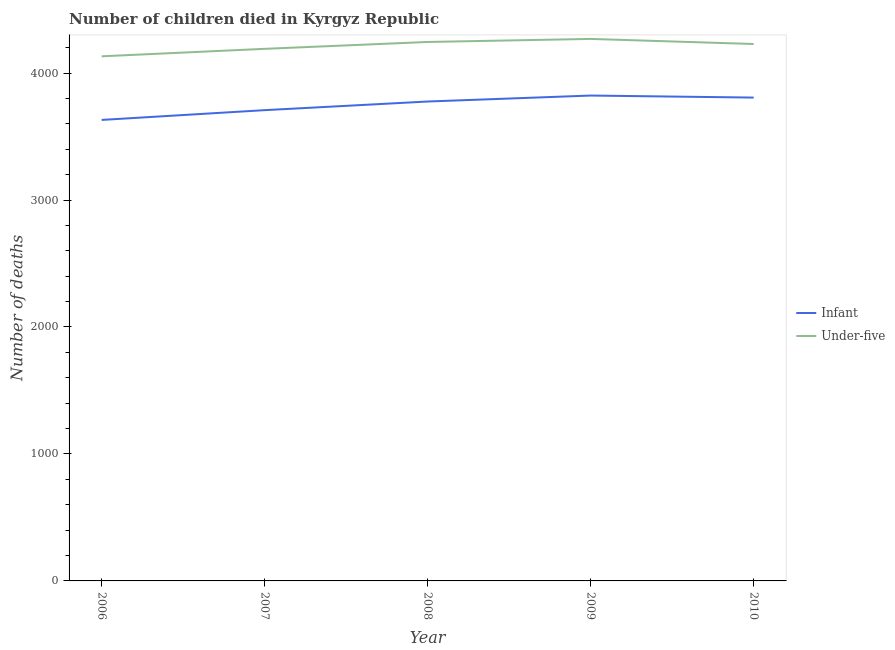How many different coloured lines are there?
Ensure brevity in your answer.  2. Does the line corresponding to number of under-five deaths intersect with the line corresponding to number of infant deaths?
Keep it short and to the point. No. What is the number of under-five deaths in 2009?
Your answer should be very brief. 4269. Across all years, what is the maximum number of infant deaths?
Your answer should be very brief. 3823. Across all years, what is the minimum number of under-five deaths?
Make the answer very short. 4132. In which year was the number of under-five deaths minimum?
Your answer should be very brief. 2006. What is the total number of infant deaths in the graph?
Provide a short and direct response. 1.87e+04. What is the difference between the number of infant deaths in 2007 and that in 2010?
Your answer should be very brief. -99. What is the difference between the number of under-five deaths in 2008 and the number of infant deaths in 2009?
Your response must be concise. 422. What is the average number of infant deaths per year?
Provide a succinct answer. 3749. In the year 2008, what is the difference between the number of infant deaths and number of under-five deaths?
Your response must be concise. -469. What is the ratio of the number of under-five deaths in 2006 to that in 2010?
Provide a short and direct response. 0.98. Is the number of infant deaths in 2007 less than that in 2008?
Give a very brief answer. Yes. What is the difference between the highest and the second highest number of infant deaths?
Make the answer very short. 16. What is the difference between the highest and the lowest number of infant deaths?
Your response must be concise. 192. Is the number of under-five deaths strictly greater than the number of infant deaths over the years?
Your answer should be compact. Yes. Is the number of infant deaths strictly less than the number of under-five deaths over the years?
Make the answer very short. Yes. How many lines are there?
Give a very brief answer. 2. How many years are there in the graph?
Offer a terse response. 5. What is the difference between two consecutive major ticks on the Y-axis?
Keep it short and to the point. 1000. Are the values on the major ticks of Y-axis written in scientific E-notation?
Provide a short and direct response. No. Does the graph contain grids?
Ensure brevity in your answer.  No. What is the title of the graph?
Offer a very short reply. Number of children died in Kyrgyz Republic. What is the label or title of the X-axis?
Your response must be concise. Year. What is the label or title of the Y-axis?
Offer a very short reply. Number of deaths. What is the Number of deaths in Infant in 2006?
Your answer should be very brief. 3631. What is the Number of deaths in Under-five in 2006?
Your answer should be very brief. 4132. What is the Number of deaths of Infant in 2007?
Offer a very short reply. 3708. What is the Number of deaths of Under-five in 2007?
Your answer should be very brief. 4191. What is the Number of deaths in Infant in 2008?
Your answer should be compact. 3776. What is the Number of deaths in Under-five in 2008?
Keep it short and to the point. 4245. What is the Number of deaths of Infant in 2009?
Ensure brevity in your answer.  3823. What is the Number of deaths of Under-five in 2009?
Offer a terse response. 4269. What is the Number of deaths in Infant in 2010?
Your answer should be compact. 3807. What is the Number of deaths in Under-five in 2010?
Offer a very short reply. 4229. Across all years, what is the maximum Number of deaths of Infant?
Your response must be concise. 3823. Across all years, what is the maximum Number of deaths in Under-five?
Keep it short and to the point. 4269. Across all years, what is the minimum Number of deaths in Infant?
Keep it short and to the point. 3631. Across all years, what is the minimum Number of deaths of Under-five?
Keep it short and to the point. 4132. What is the total Number of deaths in Infant in the graph?
Keep it short and to the point. 1.87e+04. What is the total Number of deaths of Under-five in the graph?
Offer a terse response. 2.11e+04. What is the difference between the Number of deaths in Infant in 2006 and that in 2007?
Make the answer very short. -77. What is the difference between the Number of deaths of Under-five in 2006 and that in 2007?
Make the answer very short. -59. What is the difference between the Number of deaths of Infant in 2006 and that in 2008?
Offer a very short reply. -145. What is the difference between the Number of deaths of Under-five in 2006 and that in 2008?
Your answer should be compact. -113. What is the difference between the Number of deaths in Infant in 2006 and that in 2009?
Provide a succinct answer. -192. What is the difference between the Number of deaths in Under-five in 2006 and that in 2009?
Offer a very short reply. -137. What is the difference between the Number of deaths in Infant in 2006 and that in 2010?
Provide a succinct answer. -176. What is the difference between the Number of deaths in Under-five in 2006 and that in 2010?
Keep it short and to the point. -97. What is the difference between the Number of deaths of Infant in 2007 and that in 2008?
Offer a terse response. -68. What is the difference between the Number of deaths in Under-five in 2007 and that in 2008?
Offer a terse response. -54. What is the difference between the Number of deaths in Infant in 2007 and that in 2009?
Your answer should be very brief. -115. What is the difference between the Number of deaths of Under-five in 2007 and that in 2009?
Your answer should be compact. -78. What is the difference between the Number of deaths of Infant in 2007 and that in 2010?
Keep it short and to the point. -99. What is the difference between the Number of deaths in Under-five in 2007 and that in 2010?
Your response must be concise. -38. What is the difference between the Number of deaths of Infant in 2008 and that in 2009?
Offer a very short reply. -47. What is the difference between the Number of deaths of Under-five in 2008 and that in 2009?
Provide a short and direct response. -24. What is the difference between the Number of deaths of Infant in 2008 and that in 2010?
Keep it short and to the point. -31. What is the difference between the Number of deaths in Infant in 2009 and that in 2010?
Give a very brief answer. 16. What is the difference between the Number of deaths of Under-five in 2009 and that in 2010?
Your response must be concise. 40. What is the difference between the Number of deaths in Infant in 2006 and the Number of deaths in Under-five in 2007?
Offer a terse response. -560. What is the difference between the Number of deaths in Infant in 2006 and the Number of deaths in Under-five in 2008?
Your response must be concise. -614. What is the difference between the Number of deaths in Infant in 2006 and the Number of deaths in Under-five in 2009?
Your answer should be compact. -638. What is the difference between the Number of deaths of Infant in 2006 and the Number of deaths of Under-five in 2010?
Keep it short and to the point. -598. What is the difference between the Number of deaths of Infant in 2007 and the Number of deaths of Under-five in 2008?
Provide a short and direct response. -537. What is the difference between the Number of deaths of Infant in 2007 and the Number of deaths of Under-five in 2009?
Your answer should be compact. -561. What is the difference between the Number of deaths in Infant in 2007 and the Number of deaths in Under-five in 2010?
Offer a very short reply. -521. What is the difference between the Number of deaths in Infant in 2008 and the Number of deaths in Under-five in 2009?
Make the answer very short. -493. What is the difference between the Number of deaths in Infant in 2008 and the Number of deaths in Under-five in 2010?
Your answer should be very brief. -453. What is the difference between the Number of deaths of Infant in 2009 and the Number of deaths of Under-five in 2010?
Provide a short and direct response. -406. What is the average Number of deaths of Infant per year?
Make the answer very short. 3749. What is the average Number of deaths of Under-five per year?
Ensure brevity in your answer.  4213.2. In the year 2006, what is the difference between the Number of deaths in Infant and Number of deaths in Under-five?
Your answer should be very brief. -501. In the year 2007, what is the difference between the Number of deaths of Infant and Number of deaths of Under-five?
Offer a very short reply. -483. In the year 2008, what is the difference between the Number of deaths of Infant and Number of deaths of Under-five?
Your answer should be compact. -469. In the year 2009, what is the difference between the Number of deaths of Infant and Number of deaths of Under-five?
Your answer should be very brief. -446. In the year 2010, what is the difference between the Number of deaths of Infant and Number of deaths of Under-five?
Provide a succinct answer. -422. What is the ratio of the Number of deaths in Infant in 2006 to that in 2007?
Give a very brief answer. 0.98. What is the ratio of the Number of deaths in Under-five in 2006 to that in 2007?
Offer a very short reply. 0.99. What is the ratio of the Number of deaths of Infant in 2006 to that in 2008?
Give a very brief answer. 0.96. What is the ratio of the Number of deaths in Under-five in 2006 to that in 2008?
Give a very brief answer. 0.97. What is the ratio of the Number of deaths of Infant in 2006 to that in 2009?
Offer a very short reply. 0.95. What is the ratio of the Number of deaths in Under-five in 2006 to that in 2009?
Your answer should be compact. 0.97. What is the ratio of the Number of deaths in Infant in 2006 to that in 2010?
Make the answer very short. 0.95. What is the ratio of the Number of deaths of Under-five in 2006 to that in 2010?
Your answer should be compact. 0.98. What is the ratio of the Number of deaths in Under-five in 2007 to that in 2008?
Your answer should be very brief. 0.99. What is the ratio of the Number of deaths in Infant in 2007 to that in 2009?
Provide a short and direct response. 0.97. What is the ratio of the Number of deaths of Under-five in 2007 to that in 2009?
Make the answer very short. 0.98. What is the ratio of the Number of deaths in Infant in 2009 to that in 2010?
Offer a terse response. 1. What is the ratio of the Number of deaths of Under-five in 2009 to that in 2010?
Give a very brief answer. 1.01. What is the difference between the highest and the second highest Number of deaths of Infant?
Make the answer very short. 16. What is the difference between the highest and the second highest Number of deaths of Under-five?
Your answer should be very brief. 24. What is the difference between the highest and the lowest Number of deaths of Infant?
Keep it short and to the point. 192. What is the difference between the highest and the lowest Number of deaths of Under-five?
Offer a terse response. 137. 